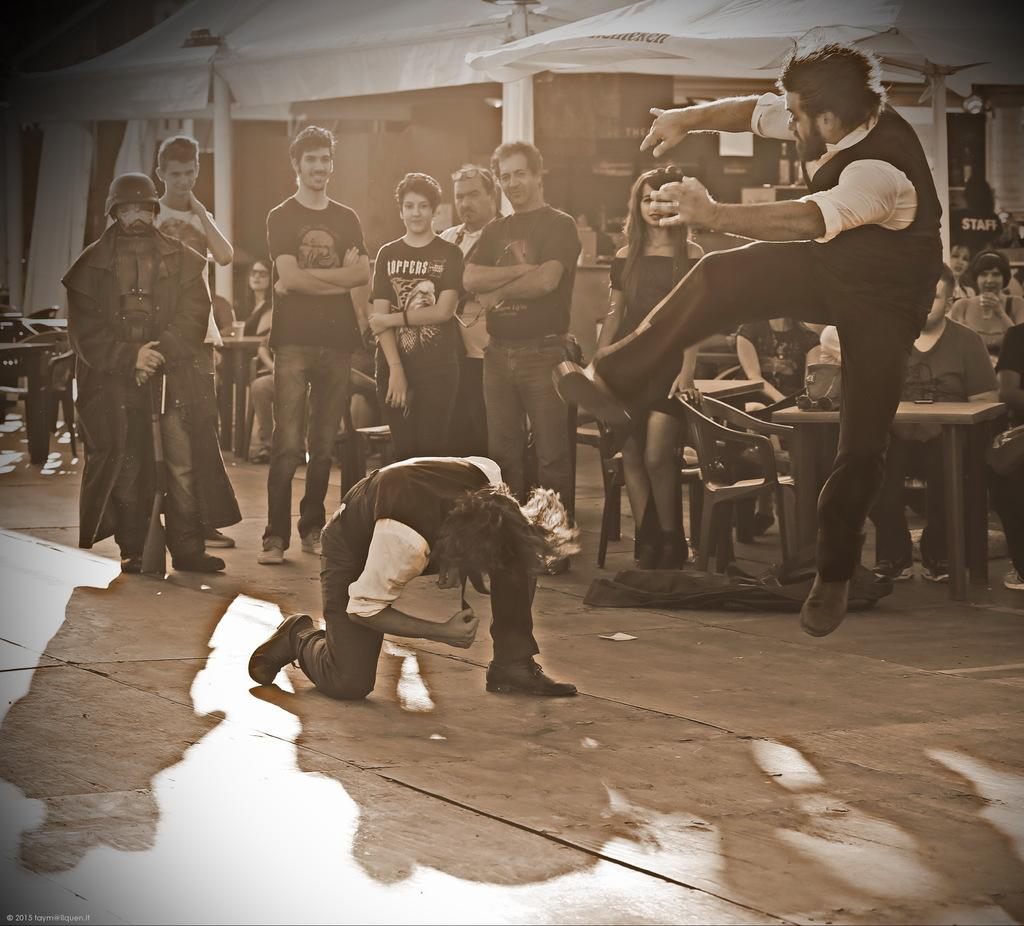What are the people in the image doing? There are people sitting and standing in the image. What is visible on the ground in the image? The ground is visible, along with bags, chairs, and tables. What structures can be seen in the image? There are poles and sheds in the image. What type of silk is draped over the sheds in the image? There is no silk present in the image; it only features people, bags, chairs, tables, poles, and sheds. 